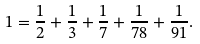<formula> <loc_0><loc_0><loc_500><loc_500>1 = \frac { 1 } { 2 } + \frac { 1 } { 3 } + \frac { 1 } { 7 } + \frac { 1 } { 7 8 } + \frac { 1 } { 9 1 } .</formula> 